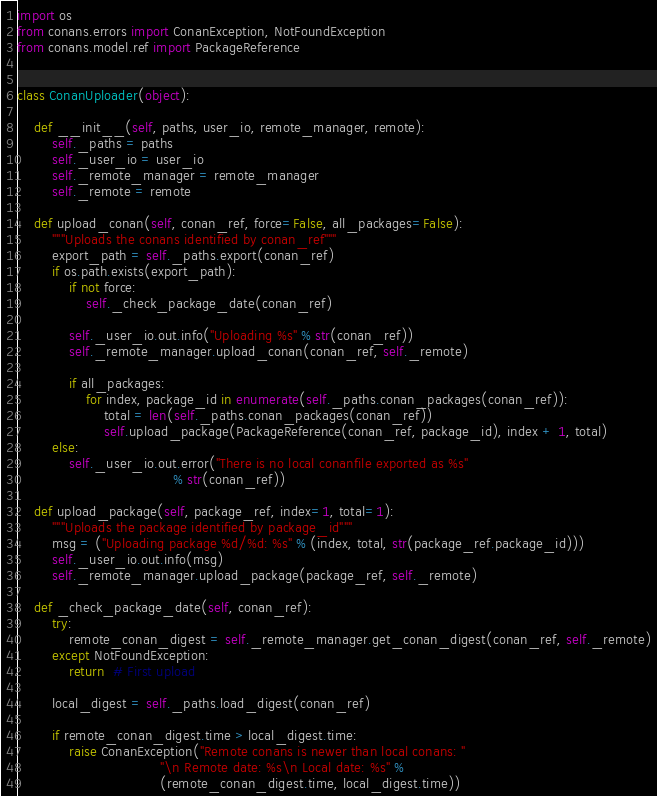Convert code to text. <code><loc_0><loc_0><loc_500><loc_500><_Python_>import os
from conans.errors import ConanException, NotFoundException
from conans.model.ref import PackageReference


class ConanUploader(object):

    def __init__(self, paths, user_io, remote_manager, remote):
        self._paths = paths
        self._user_io = user_io
        self._remote_manager = remote_manager
        self._remote = remote

    def upload_conan(self, conan_ref, force=False, all_packages=False):
        """Uploads the conans identified by conan_ref"""
        export_path = self._paths.export(conan_ref)
        if os.path.exists(export_path):
            if not force:
                self._check_package_date(conan_ref)

            self._user_io.out.info("Uploading %s" % str(conan_ref))
            self._remote_manager.upload_conan(conan_ref, self._remote)

            if all_packages:
                for index, package_id in enumerate(self._paths.conan_packages(conan_ref)):
                    total = len(self._paths.conan_packages(conan_ref))
                    self.upload_package(PackageReference(conan_ref, package_id), index + 1, total)
        else:
            self._user_io.out.error("There is no local conanfile exported as %s"
                                    % str(conan_ref))

    def upload_package(self, package_ref, index=1, total=1):
        """Uploads the package identified by package_id"""
        msg = ("Uploading package %d/%d: %s" % (index, total, str(package_ref.package_id)))
        self._user_io.out.info(msg)
        self._remote_manager.upload_package(package_ref, self._remote)

    def _check_package_date(self, conan_ref):
        try:
            remote_conan_digest = self._remote_manager.get_conan_digest(conan_ref, self._remote)
        except NotFoundException:
            return  # First upload

        local_digest = self._paths.load_digest(conan_ref)

        if remote_conan_digest.time > local_digest.time:
            raise ConanException("Remote conans is newer than local conans: "
                                 "\n Remote date: %s\n Local date: %s" %
                                 (remote_conan_digest.time, local_digest.time))
</code> 